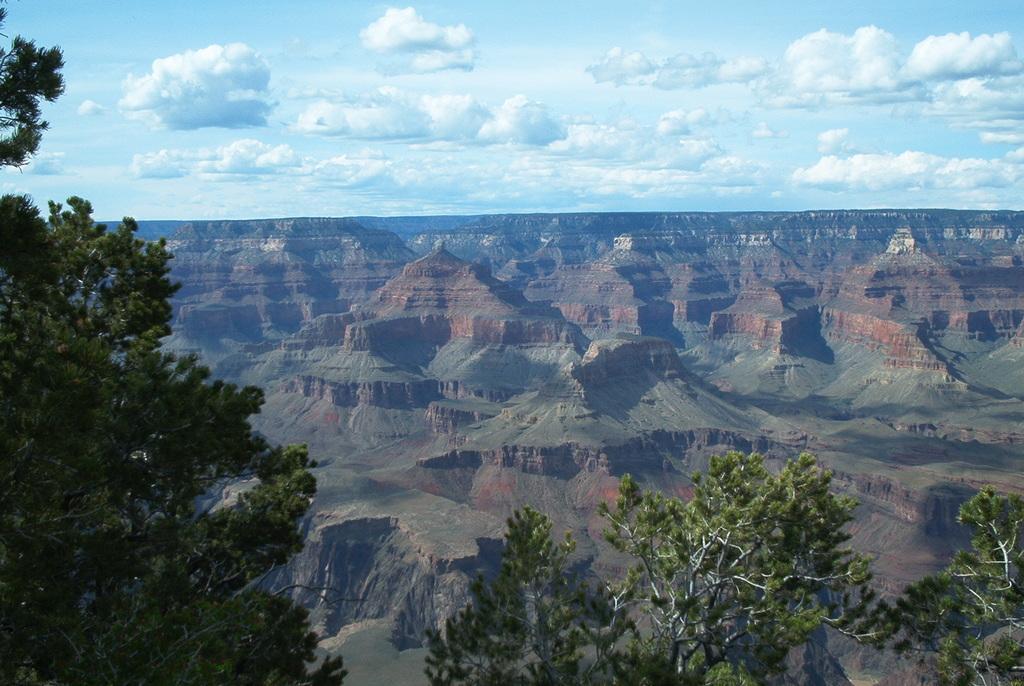How would you summarize this image in a sentence or two? In this image we can see the trees on the left side and the right side as well. In the background, we can see the grand canyon national park. This is a sky with clouds. 